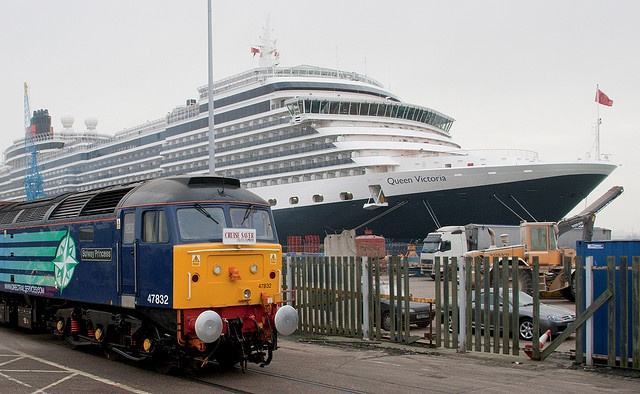Describe the objects in this image and their specific colors. I can see boat in lightgray, darkgray, black, and gray tones, train in lightgray, black, gray, navy, and orange tones, truck in lightgray, darkgray, gray, and black tones, car in lightgray, black, gray, and darkgray tones, and car in lightgray, black, gray, darkgray, and darkgreen tones in this image. 